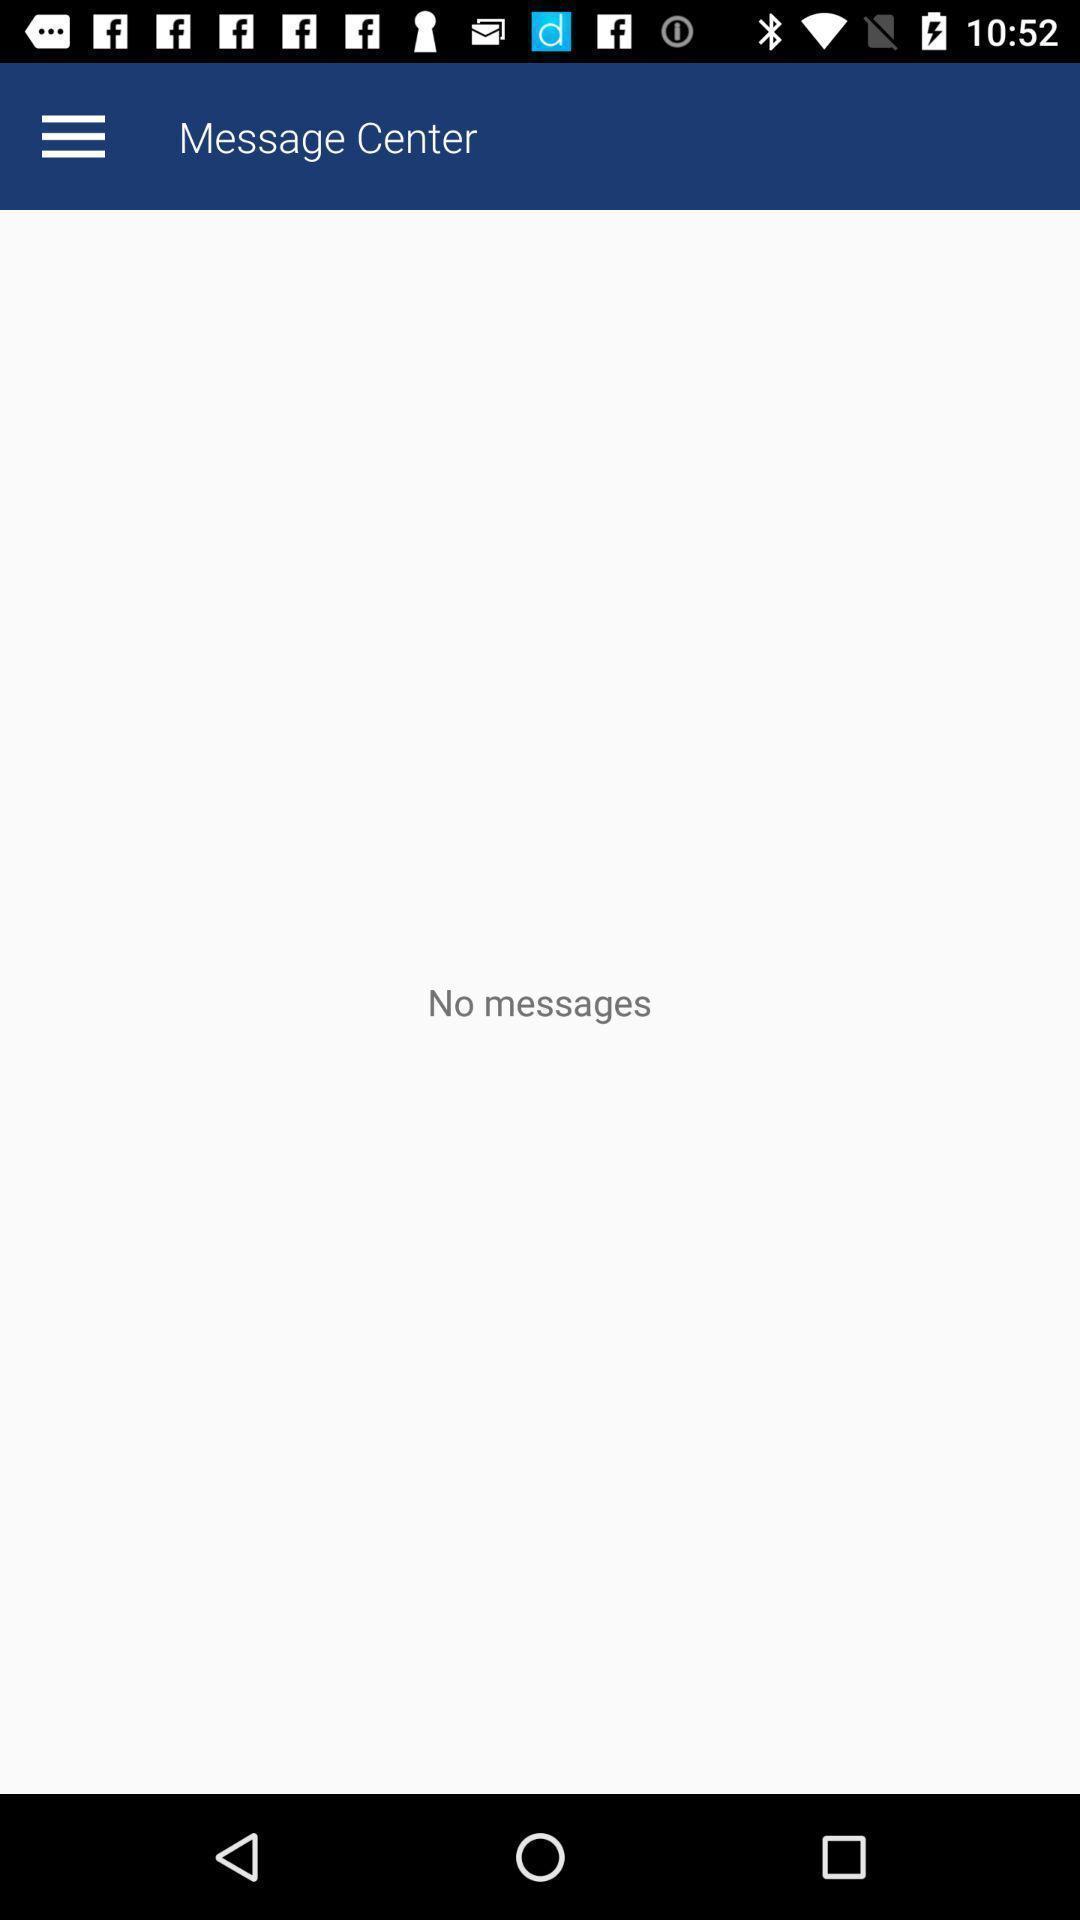Describe the visual elements of this screenshot. Screen displaying about no messages found. 